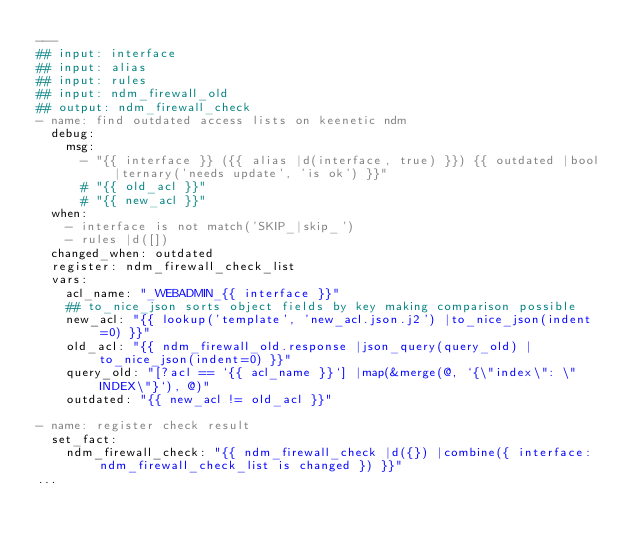<code> <loc_0><loc_0><loc_500><loc_500><_YAML_>---
## input: interface
## input: alias
## input: rules
## input: ndm_firewall_old
## output: ndm_firewall_check
- name: find outdated access lists on keenetic ndm
  debug:
    msg:
      - "{{ interface }} ({{ alias |d(interface, true) }}) {{ outdated |bool |ternary('needs update', 'is ok') }}"
      # "{{ old_acl }}"
      # "{{ new_acl }}"
  when:
    - interface is not match('SKIP_|skip_')
    - rules |d([])
  changed_when: outdated
  register: ndm_firewall_check_list
  vars:
    acl_name: "_WEBADMIN_{{ interface }}"
    ## to_nice_json sorts object fields by key making comparison possible
    new_acl: "{{ lookup('template', 'new_acl.json.j2') |to_nice_json(indent=0) }}"
    old_acl: "{{ ndm_firewall_old.response |json_query(query_old) |to_nice_json(indent=0) }}"
    query_old: "[?acl == `{{ acl_name }}`] |map(&merge(@, `{\"index\": \"INDEX\"}`), @)"
    outdated: "{{ new_acl != old_acl }}"

- name: register check result
  set_fact:
    ndm_firewall_check: "{{ ndm_firewall_check |d({}) |combine({ interface: ndm_firewall_check_list is changed }) }}"
...
</code> 